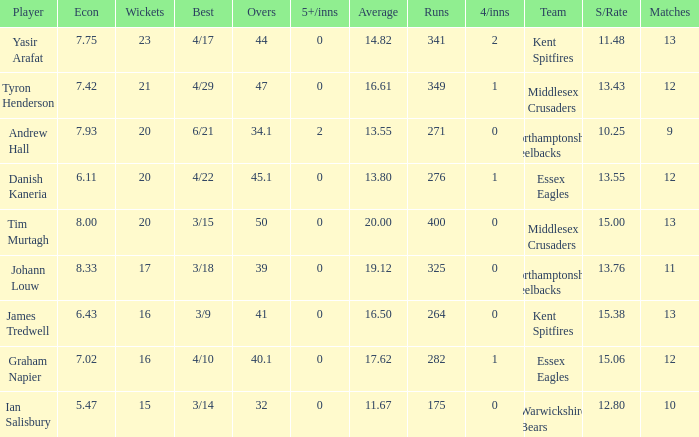Can you parse all the data within this table? {'header': ['Player', 'Econ', 'Wickets', 'Best', 'Overs', '5+/inns', 'Average', 'Runs', '4/inns', 'Team', 'S/Rate', 'Matches'], 'rows': [['Yasir Arafat', '7.75', '23', '4/17', '44', '0', '14.82', '341', '2', 'Kent Spitfires', '11.48', '13'], ['Tyron Henderson', '7.42', '21', '4/29', '47', '0', '16.61', '349', '1', 'Middlesex Crusaders', '13.43', '12'], ['Andrew Hall', '7.93', '20', '6/21', '34.1', '2', '13.55', '271', '0', 'Northamptonshire Steelbacks', '10.25', '9'], ['Danish Kaneria', '6.11', '20', '4/22', '45.1', '0', '13.80', '276', '1', 'Essex Eagles', '13.55', '12'], ['Tim Murtagh', '8.00', '20', '3/15', '50', '0', '20.00', '400', '0', 'Middlesex Crusaders', '15.00', '13'], ['Johann Louw', '8.33', '17', '3/18', '39', '0', '19.12', '325', '0', 'Northamptonshire Steelbacks', '13.76', '11'], ['James Tredwell', '6.43', '16', '3/9', '41', '0', '16.50', '264', '0', 'Kent Spitfires', '15.38', '13'], ['Graham Napier', '7.02', '16', '4/10', '40.1', '0', '17.62', '282', '1', 'Essex Eagles', '15.06', '12'], ['Ian Salisbury', '5.47', '15', '3/14', '32', '0', '11.67', '175', '0', 'Warwickshire Bears', '12.80', '10']]} Name the matches for wickets 17 11.0. 